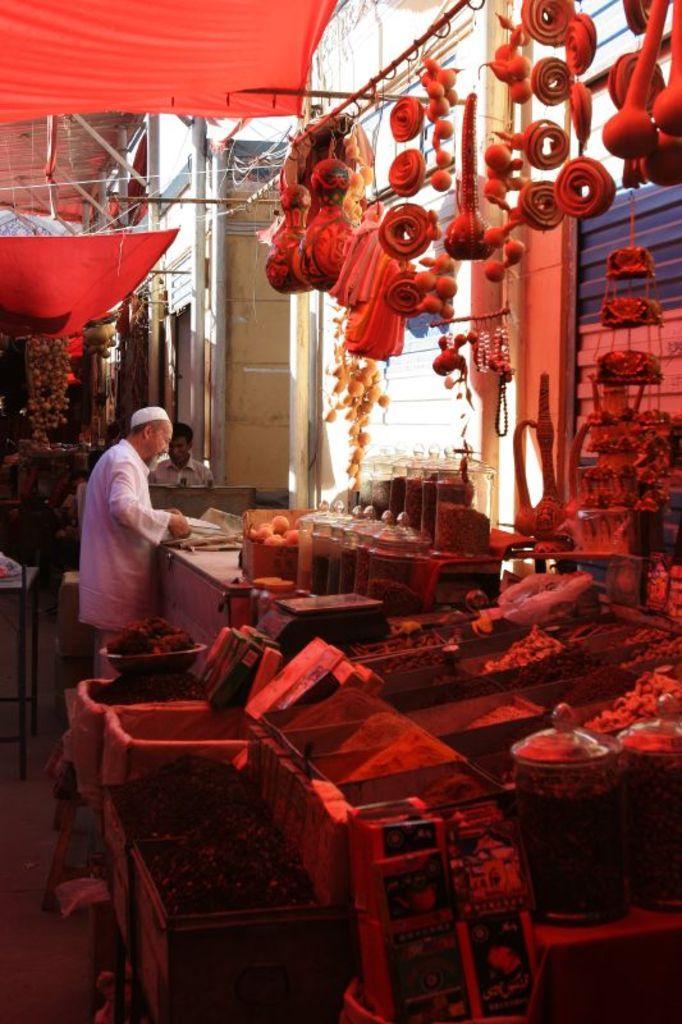How would you summarize this image in a sentence or two? In this image in the foreground there is a shop of different food. In the background there are few people. At the top there are tents. 